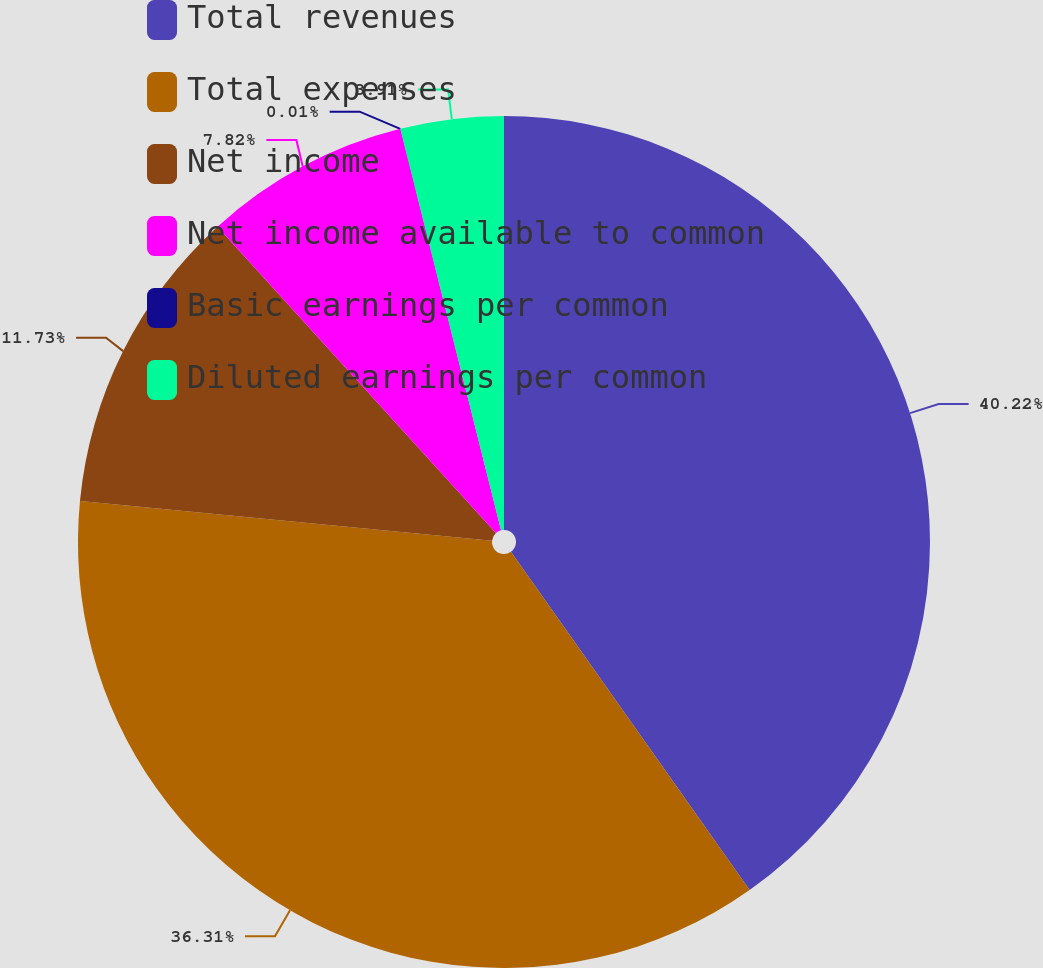Convert chart. <chart><loc_0><loc_0><loc_500><loc_500><pie_chart><fcel>Total revenues<fcel>Total expenses<fcel>Net income<fcel>Net income available to common<fcel>Basic earnings per common<fcel>Diluted earnings per common<nl><fcel>40.22%<fcel>36.31%<fcel>11.73%<fcel>7.82%<fcel>0.01%<fcel>3.91%<nl></chart> 